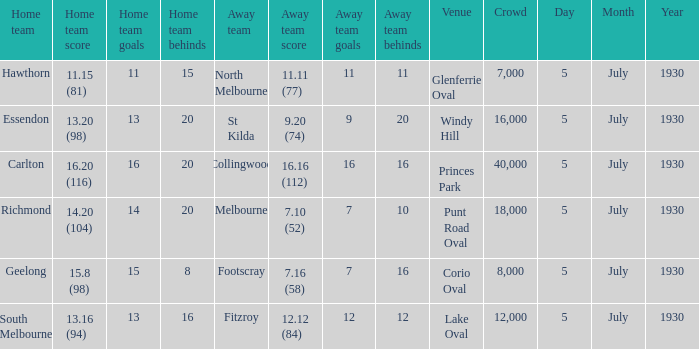Who is the home team when melbourne is the away team? 14.20 (104). 